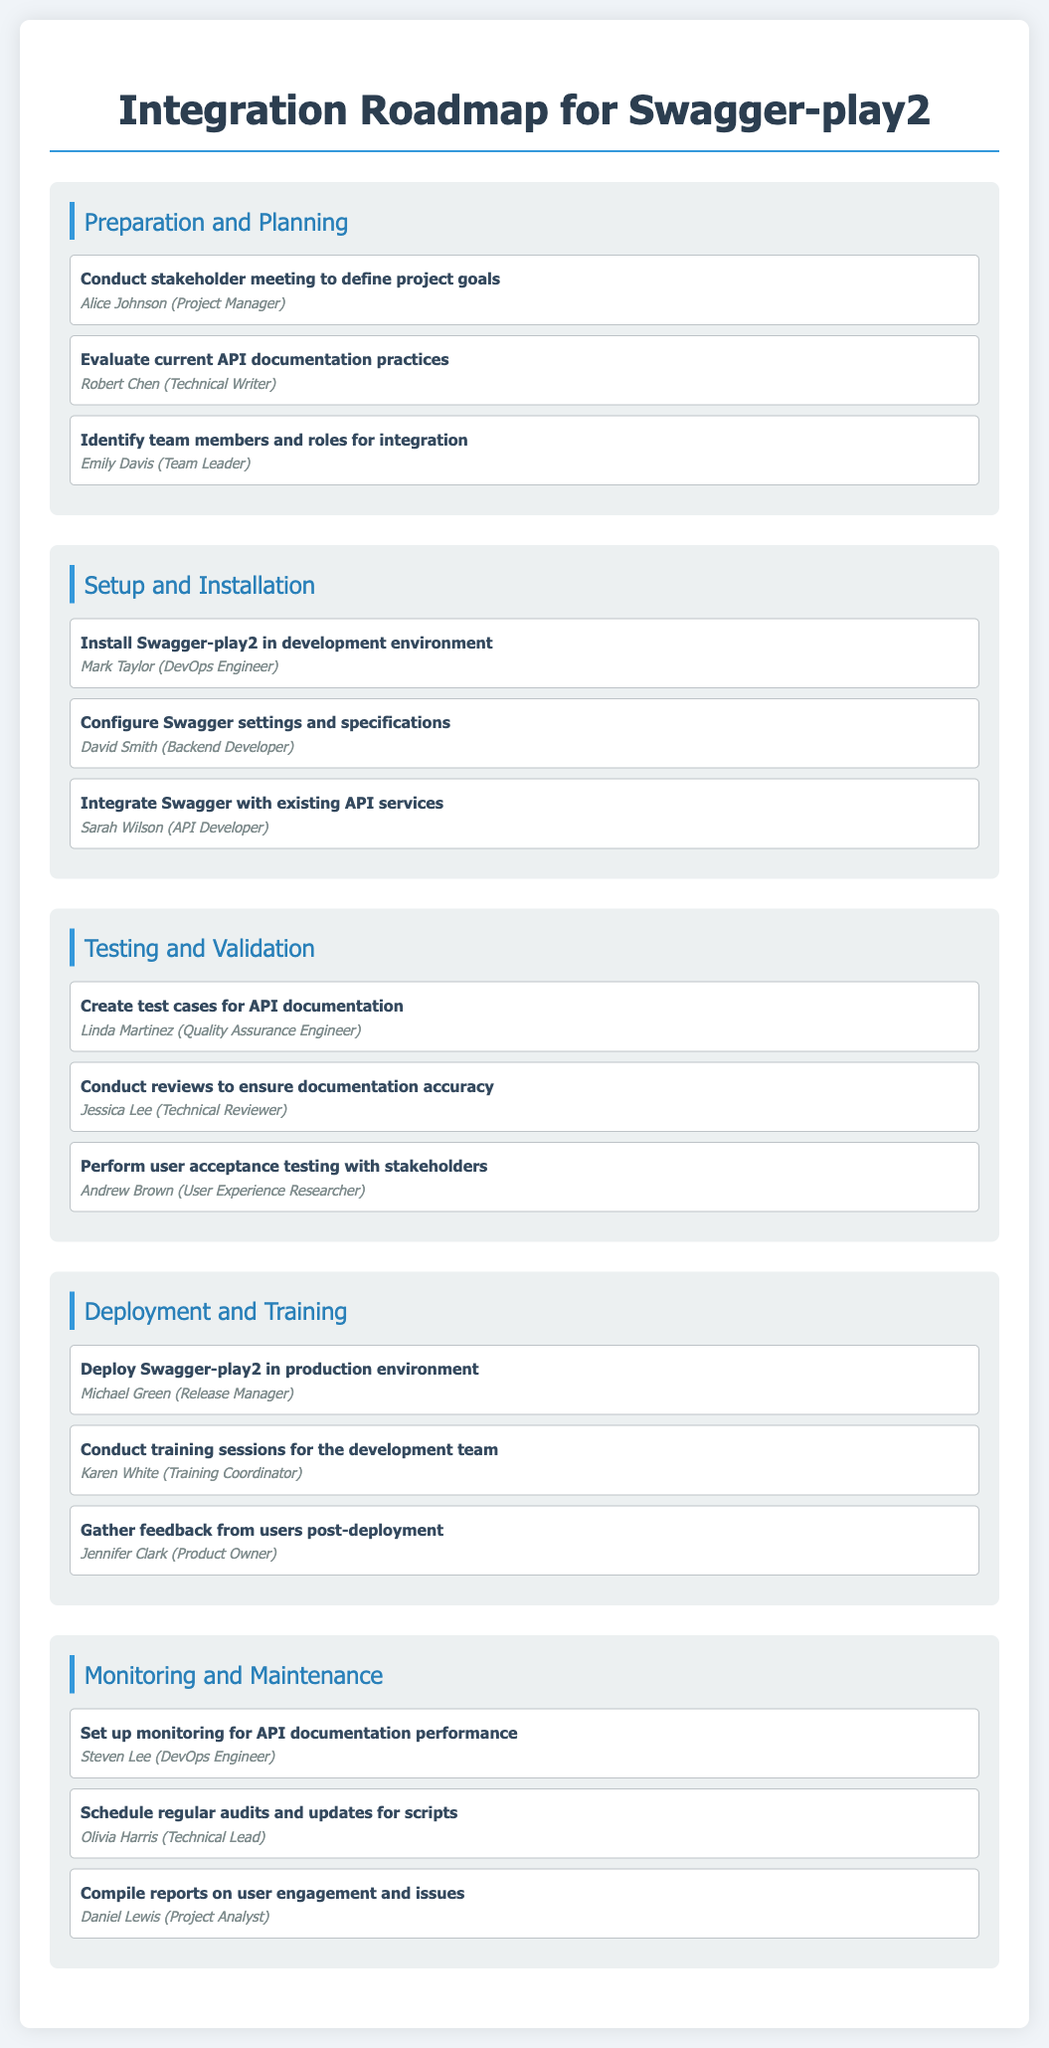What is the first phase of the integration roadmap? The first phase can be found at the top of the document and holds the title "Preparation and Planning."
Answer: Preparation and Planning Who is responsible for conducting stakeholder meetings? The document lists specific individuals responsible for tasks, and Alice Johnson is assigned to these meetings.
Answer: Alice Johnson Which team member is tasked with installing Swagger-play2? The responsibility for this task is delegated to the DevOps Engineer, who is identified as Mark Taylor in the document.
Answer: Mark Taylor How many tasks are listed under the "Testing and Validation" phase? The document details the number of tasks under each phase; there are three tasks listed under this phase.
Answer: 3 What is the last task in the deployment phase? By reviewing the tasks within the Deployment and Training phase, we can identify the last task, which is to gather feedback from users.
Answer: Gather feedback from users post-deployment Who is responsible for set up monitoring for API documentation performance? The document explicitly states that Steven Lee, the DevOps Engineer, is in charge of this task.
Answer: Steven Lee Which phase involves training sessions for the development team? The phase where training sessions are held is called "Deployment and Training," as indicated in the document.
Answer: Deployment and Training What role does Daniel Lewis hold regarding the compilation of reports? The document indicates that Daniel Lewis is a Project Analyst responsible for compiling reports.
Answer: Project Analyst How many phases are included in the integration roadmap? By counting the distinct phases mentioned in the document, we deduce the total number of phases.
Answer: 5 